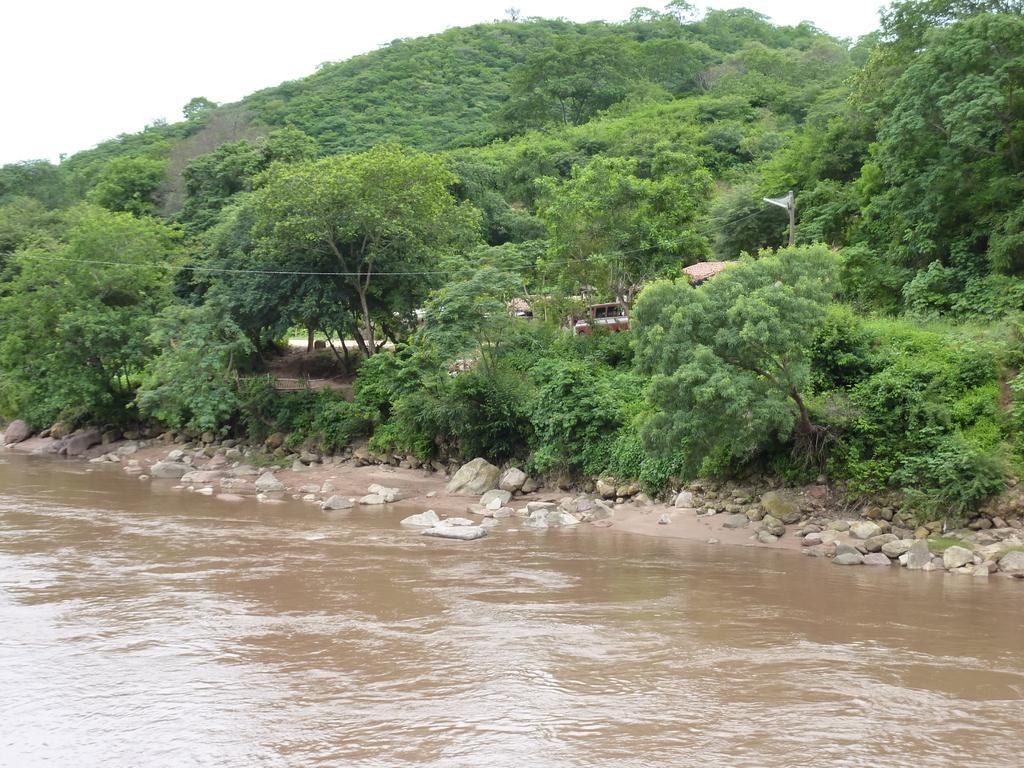Could you give a brief overview of what you see in this image? In this image there is a water. Beside water, There is a tree and an object. And there is a pole to that pole there are wires. And at the top there is a sky. 